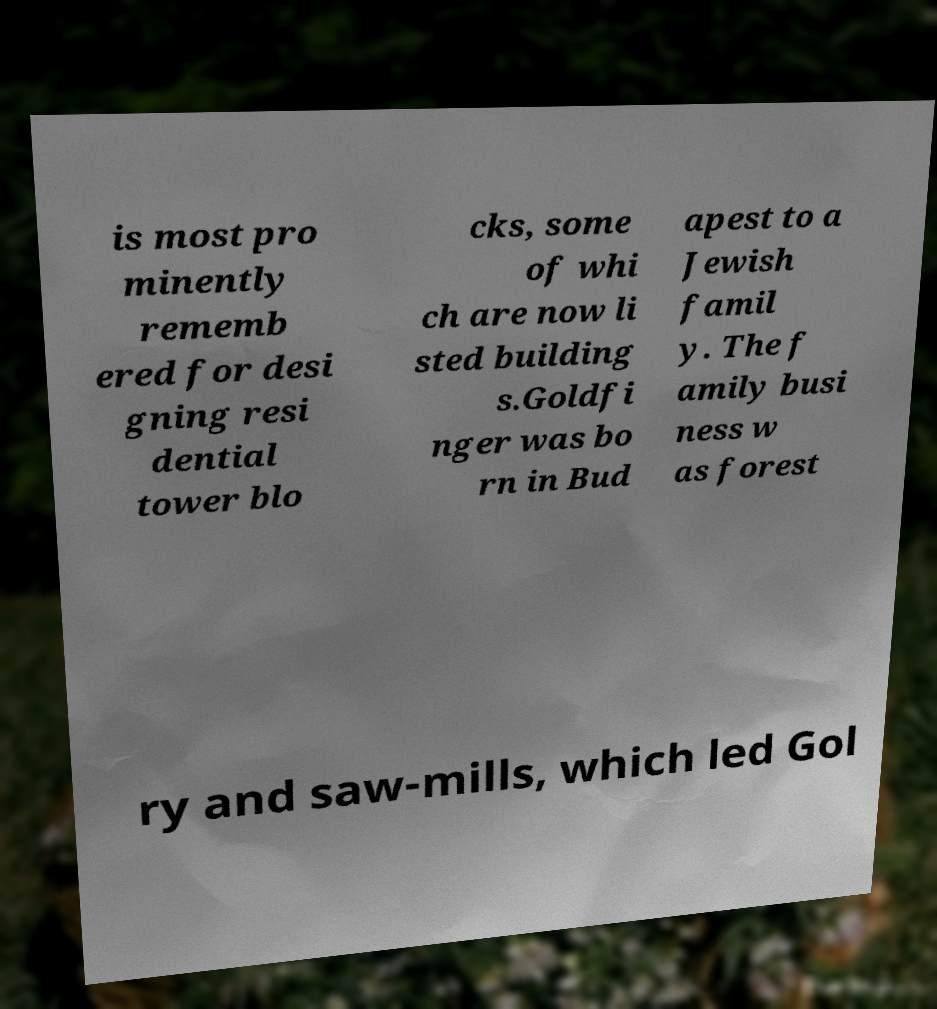Could you assist in decoding the text presented in this image and type it out clearly? is most pro minently rememb ered for desi gning resi dential tower blo cks, some of whi ch are now li sted building s.Goldfi nger was bo rn in Bud apest to a Jewish famil y. The f amily busi ness w as forest ry and saw-mills, which led Gol 